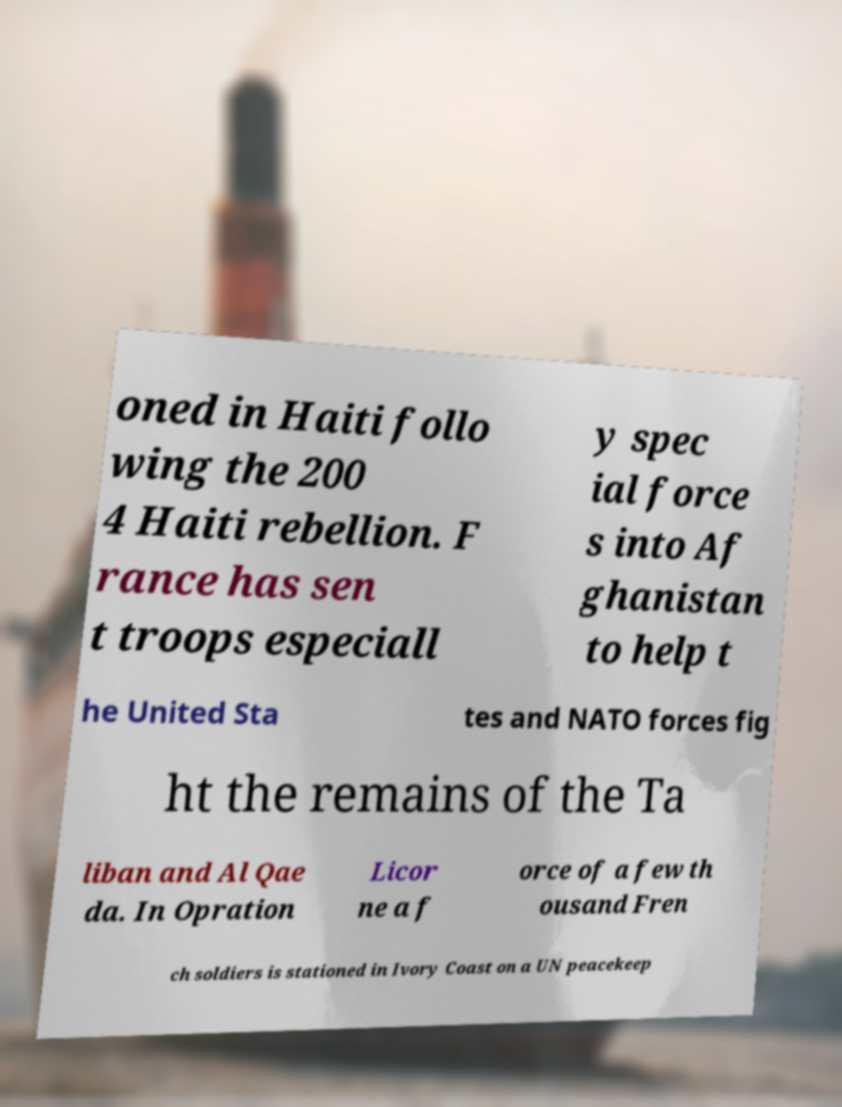There's text embedded in this image that I need extracted. Can you transcribe it verbatim? oned in Haiti follo wing the 200 4 Haiti rebellion. F rance has sen t troops especiall y spec ial force s into Af ghanistan to help t he United Sta tes and NATO forces fig ht the remains of the Ta liban and Al Qae da. In Opration Licor ne a f orce of a few th ousand Fren ch soldiers is stationed in Ivory Coast on a UN peacekeep 